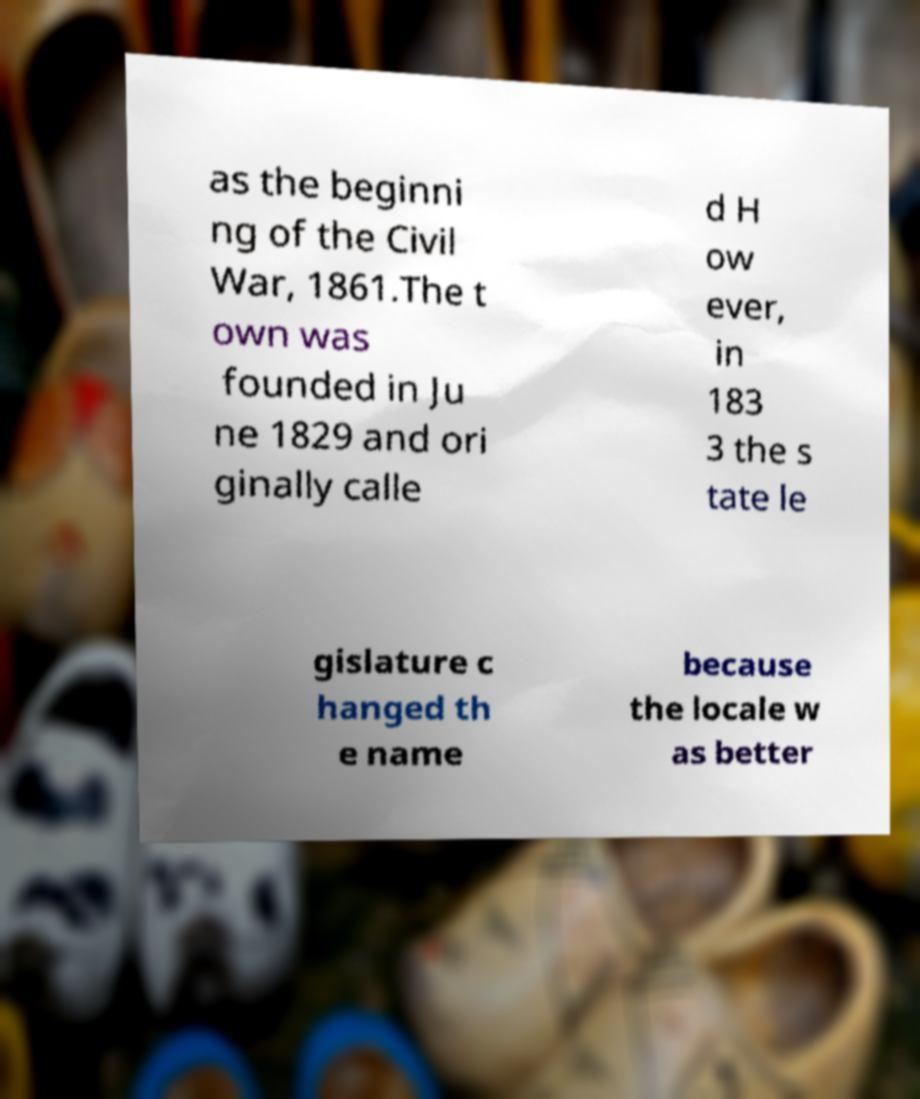Please identify and transcribe the text found in this image. as the beginni ng of the Civil War, 1861.The t own was founded in Ju ne 1829 and ori ginally calle d H ow ever, in 183 3 the s tate le gislature c hanged th e name because the locale w as better 